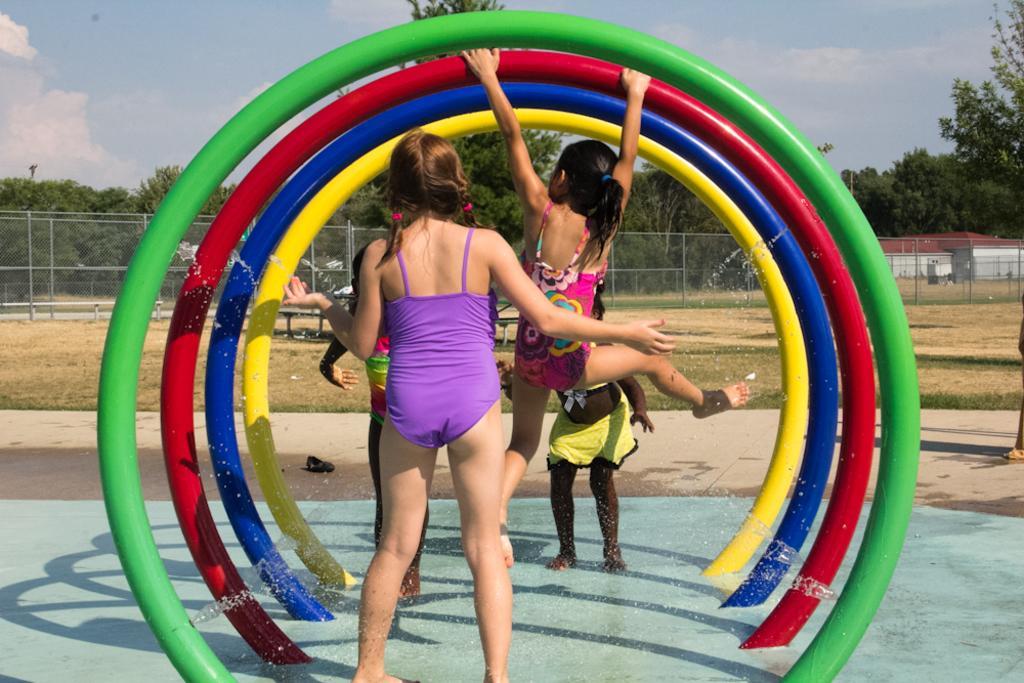Could you give a brief overview of what you see in this image? In this image, there are a few people. We can see the ground with some objects. We can see some grass, trees, a house and the fence. We can also see the sky with clouds. 